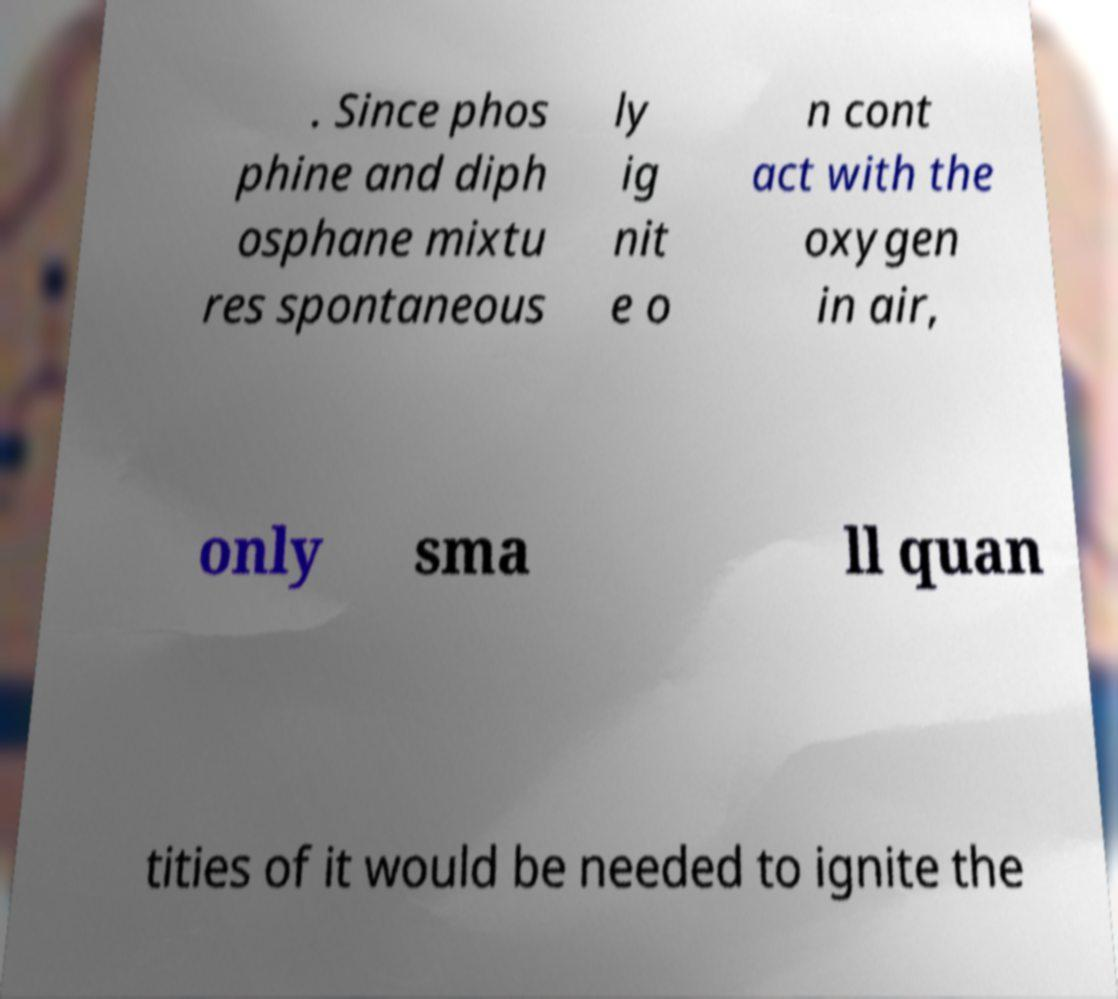There's text embedded in this image that I need extracted. Can you transcribe it verbatim? . Since phos phine and diph osphane mixtu res spontaneous ly ig nit e o n cont act with the oxygen in air, only sma ll quan tities of it would be needed to ignite the 